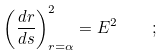<formula> <loc_0><loc_0><loc_500><loc_500>\left ( \frac { d r } { d s } \right ) ^ { 2 } _ { r = \alpha } = E ^ { 2 } \quad ;</formula> 